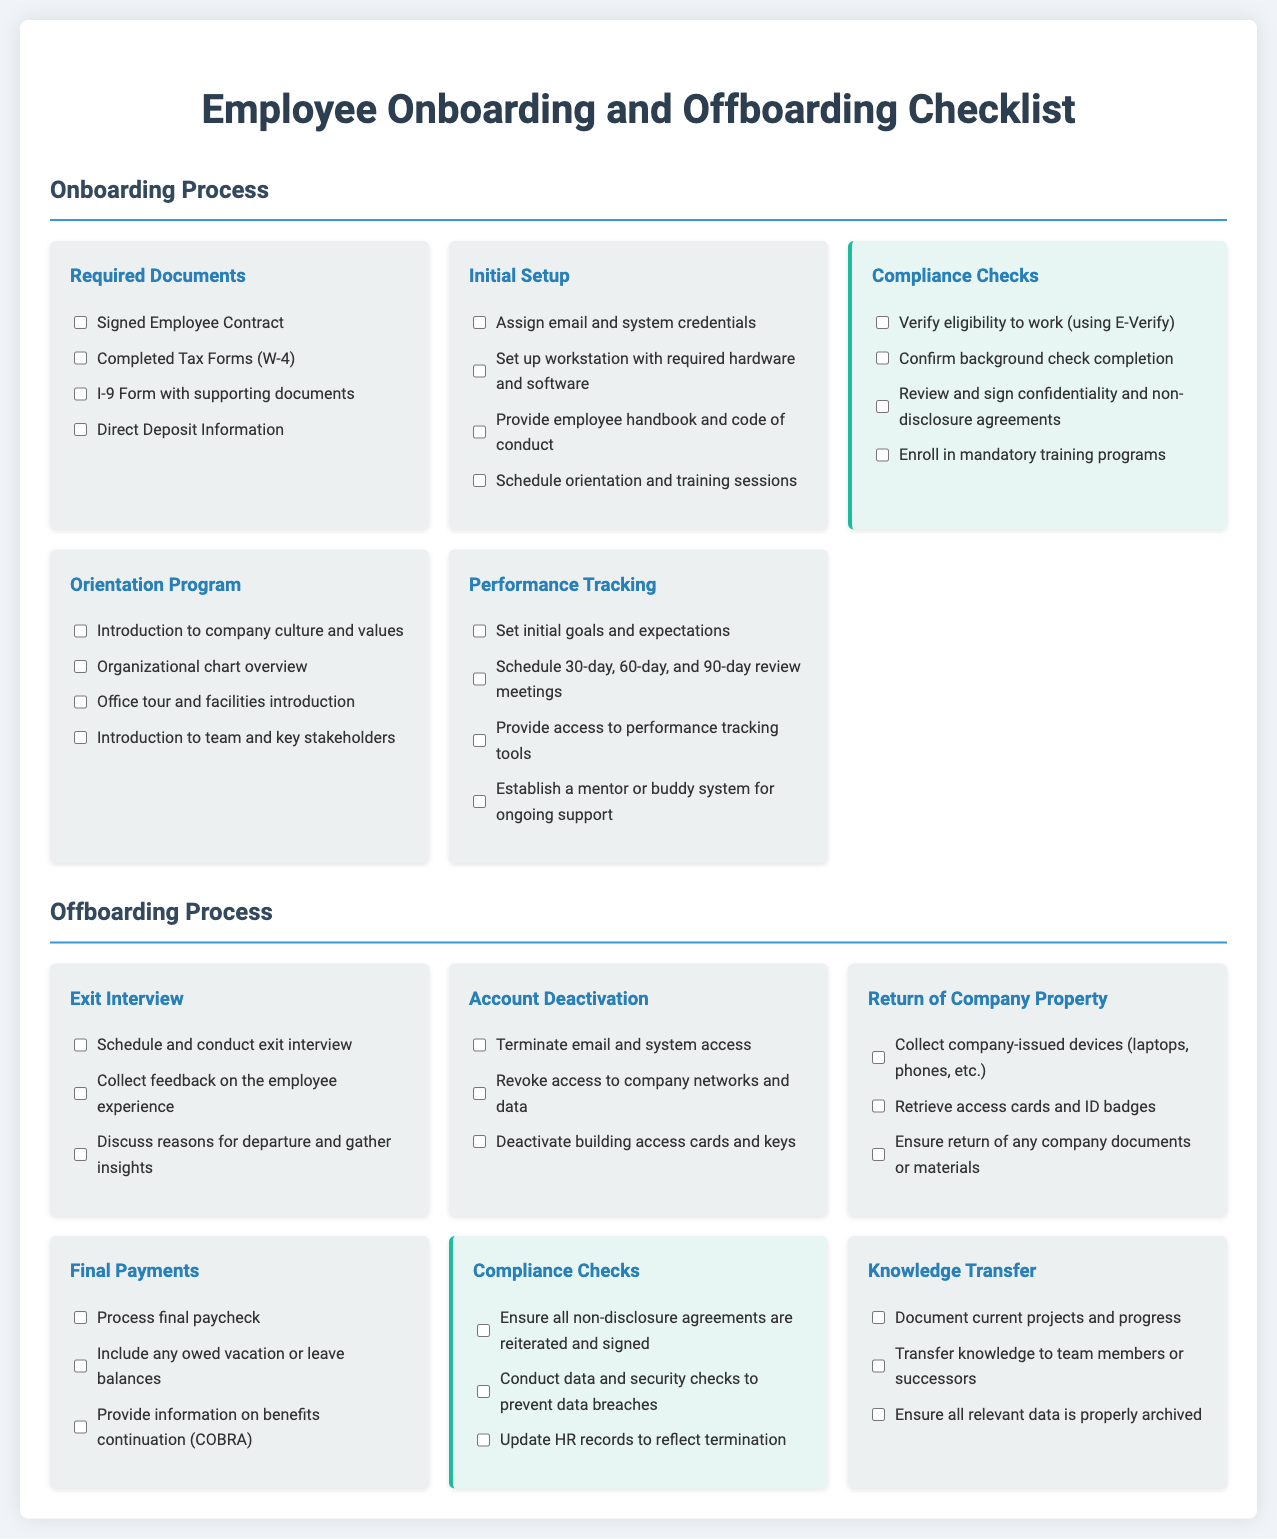What are the required documents for onboarding? The required documents are listed under the Onboarding Process section of the checklist.
Answer: Signed Employee Contract, Completed Tax Forms (W-4), I-9 Form with supporting documents, Direct Deposit Information How many initial setup tasks are there? The initial setup tasks are listed in the Initial Setup section. There are four tasks.
Answer: 4 What compliance check verifies eligibility to work? The compliance check for eligibility to work is indicated in the Compliance Checks section of the Onboarding Process.
Answer: Verify eligibility to work (using E-Verify) How many sections are there in the offboarding process? The offboarding process is divided into six sections.
Answer: 6 What should be documented during the knowledge transfer? The knowledge transfer checklist specifies what should be documented.
Answer: Document current projects and progress What does the exit interview include? The exit interview tasks are listed under the Exit Interview section.
Answer: Schedule and conduct exit interview, Collect feedback on the employee experience, Discuss reasons for departure and gather insights How many compliance checks are in the offboarding process? The number of compliance checks in the offboarding process is detailed in the Compliance Checks section.
Answer: 3 